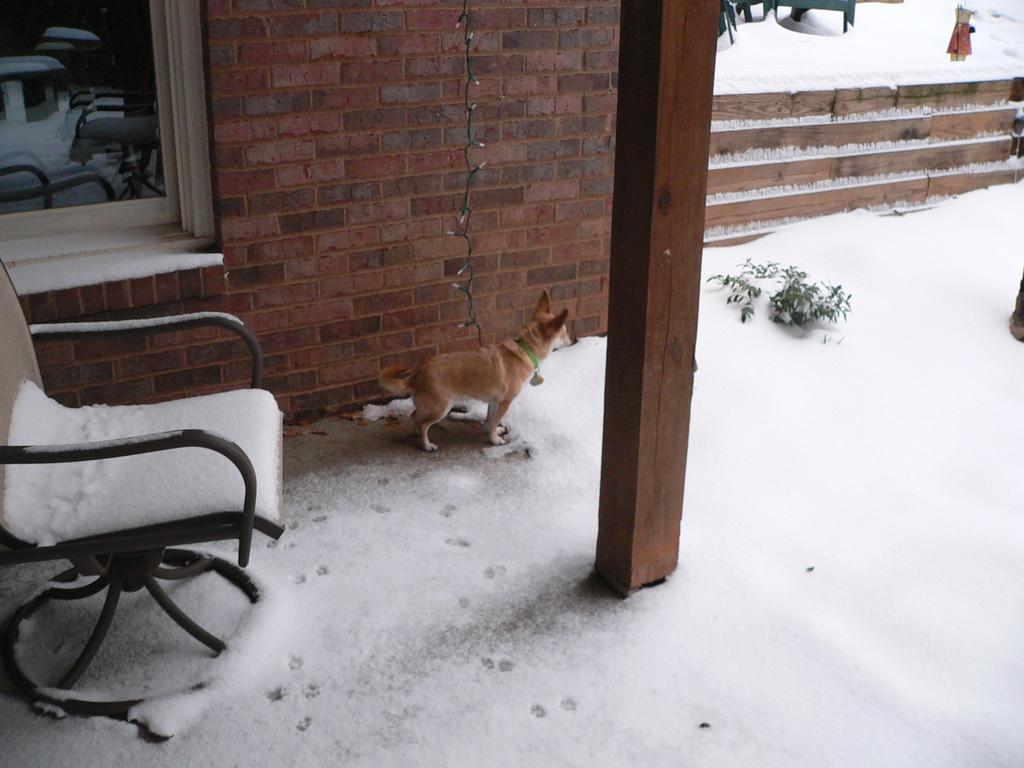Describe this image in one or two sentences. At the bottom of the picture, we see ice. In the middle of the picture, we see a wooden pillar. Behind that, we see a brown dog. Beside that, we see a plant. On the left side, we see a chair which is covered with the ice. Behind that, we see windows and a wall which is made up of bricks. Beside that, we see staircase which is covered with ice. 